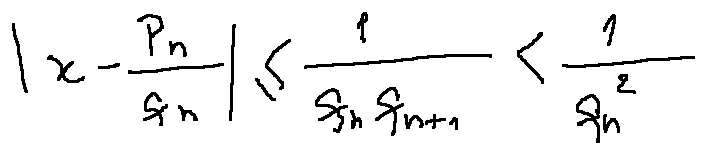<formula> <loc_0><loc_0><loc_500><loc_500>| x - \frac { p _ { n } } { q _ { n } } | \leq \frac { 1 } { q _ { n } q _ { n + 1 } } < \frac { 1 } { q _ { n } ^ { 2 } }</formula> 